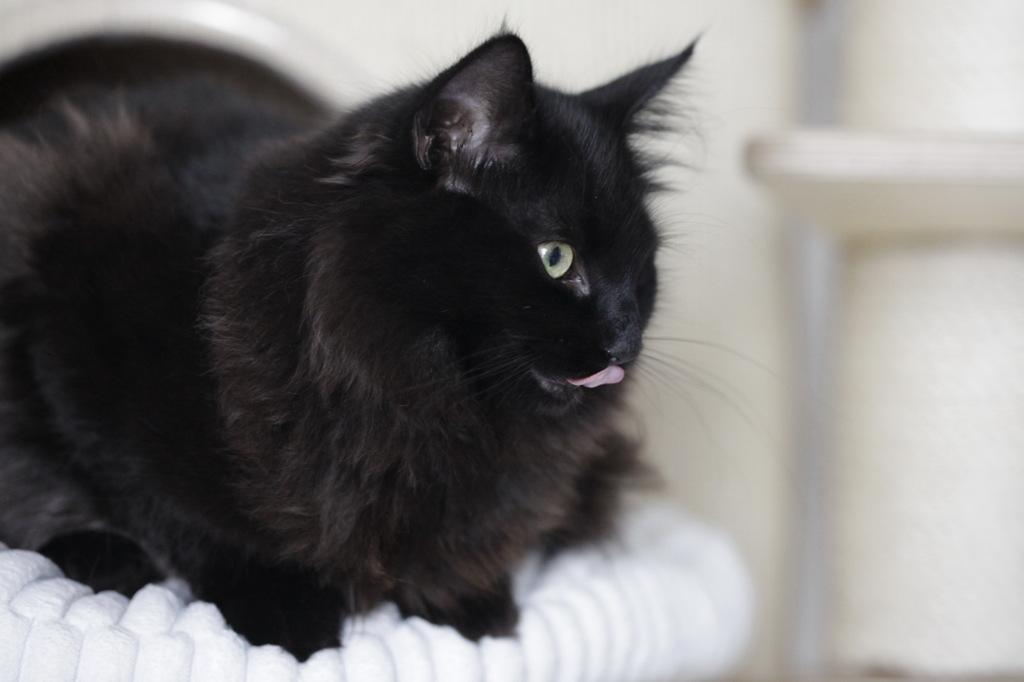What type of animal is in the image? There is a black cat in the image. What is the cat sitting on? The cat is on a white cloth. Can you describe the background of the image? The background is blurred. What type of destruction can be seen in the image? There is no destruction present in the image; it features a black cat on a white cloth with a blurred background. Can you see a giraffe in the image? No, there is no giraffe present in the image. 